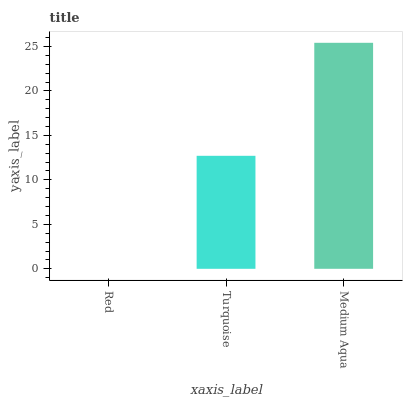Is Red the minimum?
Answer yes or no. Yes. Is Medium Aqua the maximum?
Answer yes or no. Yes. Is Turquoise the minimum?
Answer yes or no. No. Is Turquoise the maximum?
Answer yes or no. No. Is Turquoise greater than Red?
Answer yes or no. Yes. Is Red less than Turquoise?
Answer yes or no. Yes. Is Red greater than Turquoise?
Answer yes or no. No. Is Turquoise less than Red?
Answer yes or no. No. Is Turquoise the high median?
Answer yes or no. Yes. Is Turquoise the low median?
Answer yes or no. Yes. Is Medium Aqua the high median?
Answer yes or no. No. Is Medium Aqua the low median?
Answer yes or no. No. 